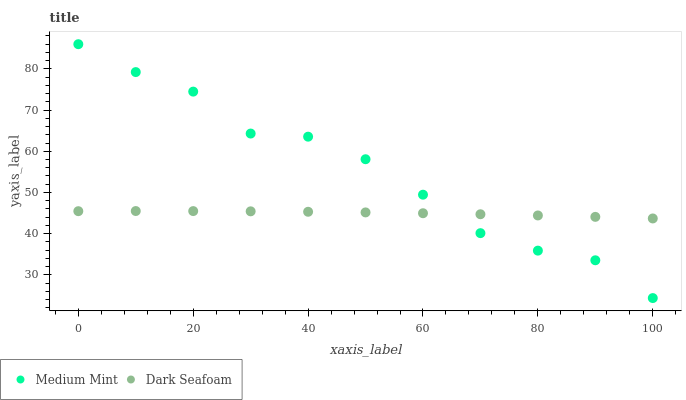Does Dark Seafoam have the minimum area under the curve?
Answer yes or no. Yes. Does Medium Mint have the maximum area under the curve?
Answer yes or no. Yes. Does Dark Seafoam have the maximum area under the curve?
Answer yes or no. No. Is Dark Seafoam the smoothest?
Answer yes or no. Yes. Is Medium Mint the roughest?
Answer yes or no. Yes. Is Dark Seafoam the roughest?
Answer yes or no. No. Does Medium Mint have the lowest value?
Answer yes or no. Yes. Does Dark Seafoam have the lowest value?
Answer yes or no. No. Does Medium Mint have the highest value?
Answer yes or no. Yes. Does Dark Seafoam have the highest value?
Answer yes or no. No. Does Dark Seafoam intersect Medium Mint?
Answer yes or no. Yes. Is Dark Seafoam less than Medium Mint?
Answer yes or no. No. Is Dark Seafoam greater than Medium Mint?
Answer yes or no. No. 